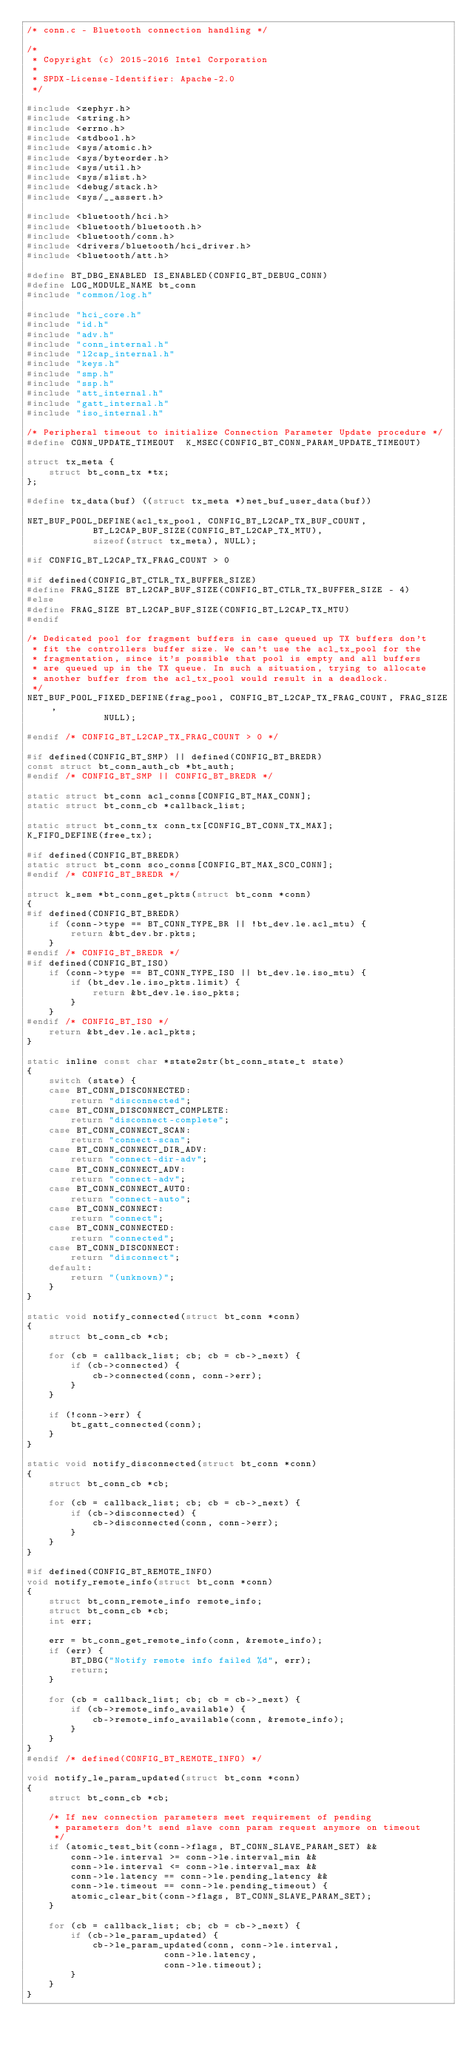<code> <loc_0><loc_0><loc_500><loc_500><_C_>/* conn.c - Bluetooth connection handling */

/*
 * Copyright (c) 2015-2016 Intel Corporation
 *
 * SPDX-License-Identifier: Apache-2.0
 */

#include <zephyr.h>
#include <string.h>
#include <errno.h>
#include <stdbool.h>
#include <sys/atomic.h>
#include <sys/byteorder.h>
#include <sys/util.h>
#include <sys/slist.h>
#include <debug/stack.h>
#include <sys/__assert.h>

#include <bluetooth/hci.h>
#include <bluetooth/bluetooth.h>
#include <bluetooth/conn.h>
#include <drivers/bluetooth/hci_driver.h>
#include <bluetooth/att.h>

#define BT_DBG_ENABLED IS_ENABLED(CONFIG_BT_DEBUG_CONN)
#define LOG_MODULE_NAME bt_conn
#include "common/log.h"

#include "hci_core.h"
#include "id.h"
#include "adv.h"
#include "conn_internal.h"
#include "l2cap_internal.h"
#include "keys.h"
#include "smp.h"
#include "ssp.h"
#include "att_internal.h"
#include "gatt_internal.h"
#include "iso_internal.h"

/* Peripheral timeout to initialize Connection Parameter Update procedure */
#define CONN_UPDATE_TIMEOUT  K_MSEC(CONFIG_BT_CONN_PARAM_UPDATE_TIMEOUT)

struct tx_meta {
	struct bt_conn_tx *tx;
};

#define tx_data(buf) ((struct tx_meta *)net_buf_user_data(buf))

NET_BUF_POOL_DEFINE(acl_tx_pool, CONFIG_BT_L2CAP_TX_BUF_COUNT,
		    BT_L2CAP_BUF_SIZE(CONFIG_BT_L2CAP_TX_MTU),
		    sizeof(struct tx_meta), NULL);

#if CONFIG_BT_L2CAP_TX_FRAG_COUNT > 0

#if defined(CONFIG_BT_CTLR_TX_BUFFER_SIZE)
#define FRAG_SIZE BT_L2CAP_BUF_SIZE(CONFIG_BT_CTLR_TX_BUFFER_SIZE - 4)
#else
#define FRAG_SIZE BT_L2CAP_BUF_SIZE(CONFIG_BT_L2CAP_TX_MTU)
#endif

/* Dedicated pool for fragment buffers in case queued up TX buffers don't
 * fit the controllers buffer size. We can't use the acl_tx_pool for the
 * fragmentation, since it's possible that pool is empty and all buffers
 * are queued up in the TX queue. In such a situation, trying to allocate
 * another buffer from the acl_tx_pool would result in a deadlock.
 */
NET_BUF_POOL_FIXED_DEFINE(frag_pool, CONFIG_BT_L2CAP_TX_FRAG_COUNT, FRAG_SIZE,
			  NULL);

#endif /* CONFIG_BT_L2CAP_TX_FRAG_COUNT > 0 */

#if defined(CONFIG_BT_SMP) || defined(CONFIG_BT_BREDR)
const struct bt_conn_auth_cb *bt_auth;
#endif /* CONFIG_BT_SMP || CONFIG_BT_BREDR */

static struct bt_conn acl_conns[CONFIG_BT_MAX_CONN];
static struct bt_conn_cb *callback_list;

static struct bt_conn_tx conn_tx[CONFIG_BT_CONN_TX_MAX];
K_FIFO_DEFINE(free_tx);

#if defined(CONFIG_BT_BREDR)
static struct bt_conn sco_conns[CONFIG_BT_MAX_SCO_CONN];
#endif /* CONFIG_BT_BREDR */

struct k_sem *bt_conn_get_pkts(struct bt_conn *conn)
{
#if defined(CONFIG_BT_BREDR)
	if (conn->type == BT_CONN_TYPE_BR || !bt_dev.le.acl_mtu) {
		return &bt_dev.br.pkts;
	}
#endif /* CONFIG_BT_BREDR */
#if defined(CONFIG_BT_ISO)
	if (conn->type == BT_CONN_TYPE_ISO || bt_dev.le.iso_mtu) {
		if (bt_dev.le.iso_pkts.limit) {
			return &bt_dev.le.iso_pkts;
		}
	}
#endif /* CONFIG_BT_ISO */
	return &bt_dev.le.acl_pkts;
}

static inline const char *state2str(bt_conn_state_t state)
{
	switch (state) {
	case BT_CONN_DISCONNECTED:
		return "disconnected";
	case BT_CONN_DISCONNECT_COMPLETE:
		return "disconnect-complete";
	case BT_CONN_CONNECT_SCAN:
		return "connect-scan";
	case BT_CONN_CONNECT_DIR_ADV:
		return "connect-dir-adv";
	case BT_CONN_CONNECT_ADV:
		return "connect-adv";
	case BT_CONN_CONNECT_AUTO:
		return "connect-auto";
	case BT_CONN_CONNECT:
		return "connect";
	case BT_CONN_CONNECTED:
		return "connected";
	case BT_CONN_DISCONNECT:
		return "disconnect";
	default:
		return "(unknown)";
	}
}

static void notify_connected(struct bt_conn *conn)
{
	struct bt_conn_cb *cb;

	for (cb = callback_list; cb; cb = cb->_next) {
		if (cb->connected) {
			cb->connected(conn, conn->err);
		}
	}

	if (!conn->err) {
		bt_gatt_connected(conn);
	}
}

static void notify_disconnected(struct bt_conn *conn)
{
	struct bt_conn_cb *cb;

	for (cb = callback_list; cb; cb = cb->_next) {
		if (cb->disconnected) {
			cb->disconnected(conn, conn->err);
		}
	}
}

#if defined(CONFIG_BT_REMOTE_INFO)
void notify_remote_info(struct bt_conn *conn)
{
	struct bt_conn_remote_info remote_info;
	struct bt_conn_cb *cb;
	int err;

	err = bt_conn_get_remote_info(conn, &remote_info);
	if (err) {
		BT_DBG("Notify remote info failed %d", err);
		return;
	}

	for (cb = callback_list; cb; cb = cb->_next) {
		if (cb->remote_info_available) {
			cb->remote_info_available(conn, &remote_info);
		}
	}
}
#endif /* defined(CONFIG_BT_REMOTE_INFO) */

void notify_le_param_updated(struct bt_conn *conn)
{
	struct bt_conn_cb *cb;

	/* If new connection parameters meet requirement of pending
	 * parameters don't send slave conn param request anymore on timeout
	 */
	if (atomic_test_bit(conn->flags, BT_CONN_SLAVE_PARAM_SET) &&
	    conn->le.interval >= conn->le.interval_min &&
	    conn->le.interval <= conn->le.interval_max &&
	    conn->le.latency == conn->le.pending_latency &&
	    conn->le.timeout == conn->le.pending_timeout) {
		atomic_clear_bit(conn->flags, BT_CONN_SLAVE_PARAM_SET);
	}

	for (cb = callback_list; cb; cb = cb->_next) {
		if (cb->le_param_updated) {
			cb->le_param_updated(conn, conn->le.interval,
					     conn->le.latency,
					     conn->le.timeout);
		}
	}
}
</code> 